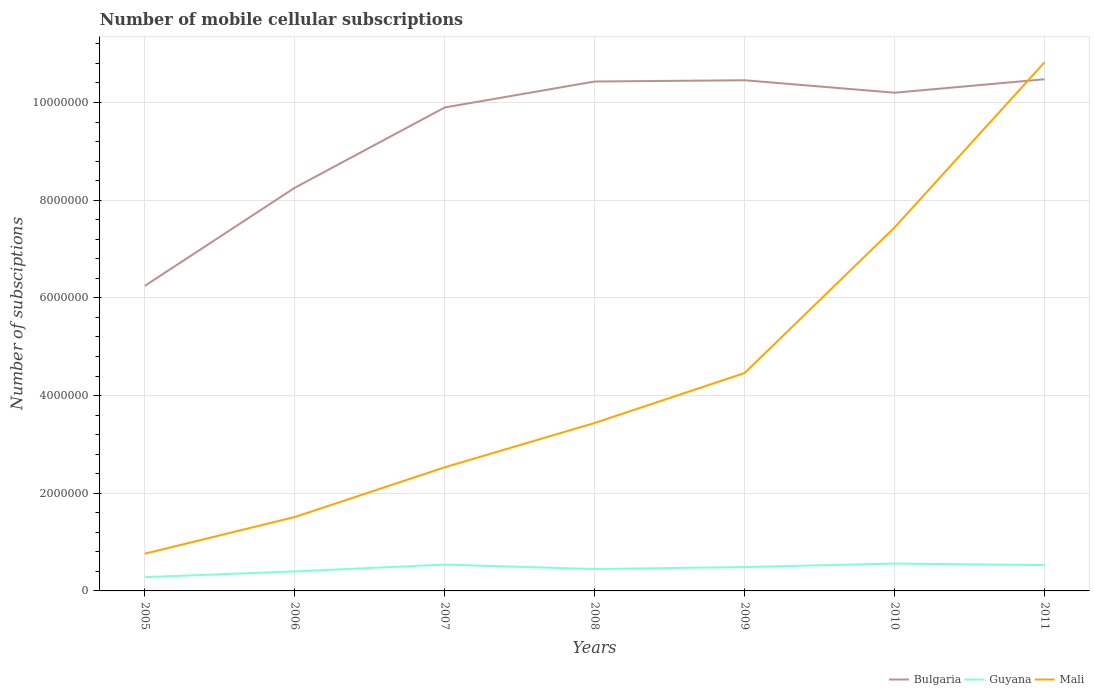How many different coloured lines are there?
Provide a short and direct response. 3. Is the number of lines equal to the number of legend labels?
Offer a terse response. Yes. Across all years, what is the maximum number of mobile cellular subscriptions in Bulgaria?
Keep it short and to the point. 6.24e+06. What is the total number of mobile cellular subscriptions in Bulgaria in the graph?
Provide a short and direct response. -2.18e+06. What is the difference between the highest and the second highest number of mobile cellular subscriptions in Guyana?
Your answer should be very brief. 2.79e+05. What is the difference between the highest and the lowest number of mobile cellular subscriptions in Bulgaria?
Offer a very short reply. 5. How many years are there in the graph?
Offer a terse response. 7. What is the difference between two consecutive major ticks on the Y-axis?
Offer a very short reply. 2.00e+06. Does the graph contain any zero values?
Provide a short and direct response. No. Does the graph contain grids?
Your answer should be very brief. Yes. How are the legend labels stacked?
Offer a very short reply. Horizontal. What is the title of the graph?
Keep it short and to the point. Number of mobile cellular subscriptions. What is the label or title of the X-axis?
Offer a terse response. Years. What is the label or title of the Y-axis?
Keep it short and to the point. Number of subsciptions. What is the Number of subsciptions in Bulgaria in 2005?
Provide a succinct answer. 6.24e+06. What is the Number of subsciptions in Guyana in 2005?
Offer a very short reply. 2.81e+05. What is the Number of subsciptions in Mali in 2005?
Offer a terse response. 7.62e+05. What is the Number of subsciptions of Bulgaria in 2006?
Provide a short and direct response. 8.25e+06. What is the Number of subsciptions in Mali in 2006?
Your answer should be very brief. 1.51e+06. What is the Number of subsciptions in Bulgaria in 2007?
Offer a terse response. 9.90e+06. What is the Number of subsciptions of Guyana in 2007?
Provide a short and direct response. 5.39e+05. What is the Number of subsciptions of Mali in 2007?
Your answer should be compact. 2.53e+06. What is the Number of subsciptions in Bulgaria in 2008?
Provide a short and direct response. 1.04e+07. What is the Number of subsciptions in Guyana in 2008?
Keep it short and to the point. 4.48e+05. What is the Number of subsciptions in Mali in 2008?
Offer a terse response. 3.44e+06. What is the Number of subsciptions of Bulgaria in 2009?
Offer a very short reply. 1.05e+07. What is the Number of subsciptions of Guyana in 2009?
Ensure brevity in your answer.  4.89e+05. What is the Number of subsciptions of Mali in 2009?
Offer a very short reply. 4.46e+06. What is the Number of subsciptions of Bulgaria in 2010?
Make the answer very short. 1.02e+07. What is the Number of subsciptions of Guyana in 2010?
Keep it short and to the point. 5.60e+05. What is the Number of subsciptions of Mali in 2010?
Your response must be concise. 7.44e+06. What is the Number of subsciptions in Bulgaria in 2011?
Make the answer very short. 1.05e+07. What is the Number of subsciptions of Guyana in 2011?
Make the answer very short. 5.29e+05. What is the Number of subsciptions in Mali in 2011?
Offer a very short reply. 1.08e+07. Across all years, what is the maximum Number of subsciptions of Bulgaria?
Provide a succinct answer. 1.05e+07. Across all years, what is the maximum Number of subsciptions of Guyana?
Your answer should be compact. 5.60e+05. Across all years, what is the maximum Number of subsciptions of Mali?
Offer a very short reply. 1.08e+07. Across all years, what is the minimum Number of subsciptions of Bulgaria?
Offer a very short reply. 6.24e+06. Across all years, what is the minimum Number of subsciptions in Guyana?
Give a very brief answer. 2.81e+05. Across all years, what is the minimum Number of subsciptions in Mali?
Your answer should be compact. 7.62e+05. What is the total Number of subsciptions in Bulgaria in the graph?
Your answer should be very brief. 6.60e+07. What is the total Number of subsciptions in Guyana in the graph?
Offer a very short reply. 3.25e+06. What is the total Number of subsciptions in Mali in the graph?
Your answer should be compact. 3.10e+07. What is the difference between the Number of subsciptions in Bulgaria in 2005 and that in 2006?
Keep it short and to the point. -2.01e+06. What is the difference between the Number of subsciptions of Guyana in 2005 and that in 2006?
Keep it short and to the point. -1.19e+05. What is the difference between the Number of subsciptions of Mali in 2005 and that in 2006?
Give a very brief answer. -7.51e+05. What is the difference between the Number of subsciptions of Bulgaria in 2005 and that in 2007?
Ensure brevity in your answer.  -3.65e+06. What is the difference between the Number of subsciptions of Guyana in 2005 and that in 2007?
Keep it short and to the point. -2.57e+05. What is the difference between the Number of subsciptions in Mali in 2005 and that in 2007?
Provide a short and direct response. -1.77e+06. What is the difference between the Number of subsciptions of Bulgaria in 2005 and that in 2008?
Your response must be concise. -4.18e+06. What is the difference between the Number of subsciptions of Guyana in 2005 and that in 2008?
Make the answer very short. -1.66e+05. What is the difference between the Number of subsciptions in Mali in 2005 and that in 2008?
Offer a very short reply. -2.68e+06. What is the difference between the Number of subsciptions of Bulgaria in 2005 and that in 2009?
Give a very brief answer. -4.21e+06. What is the difference between the Number of subsciptions of Guyana in 2005 and that in 2009?
Your answer should be very brief. -2.07e+05. What is the difference between the Number of subsciptions of Mali in 2005 and that in 2009?
Your response must be concise. -3.70e+06. What is the difference between the Number of subsciptions of Bulgaria in 2005 and that in 2010?
Offer a terse response. -3.96e+06. What is the difference between the Number of subsciptions of Guyana in 2005 and that in 2010?
Provide a short and direct response. -2.79e+05. What is the difference between the Number of subsciptions of Mali in 2005 and that in 2010?
Your answer should be very brief. -6.68e+06. What is the difference between the Number of subsciptions in Bulgaria in 2005 and that in 2011?
Make the answer very short. -4.23e+06. What is the difference between the Number of subsciptions of Guyana in 2005 and that in 2011?
Keep it short and to the point. -2.47e+05. What is the difference between the Number of subsciptions in Mali in 2005 and that in 2011?
Provide a succinct answer. -1.01e+07. What is the difference between the Number of subsciptions in Bulgaria in 2006 and that in 2007?
Your answer should be compact. -1.64e+06. What is the difference between the Number of subsciptions in Guyana in 2006 and that in 2007?
Ensure brevity in your answer.  -1.39e+05. What is the difference between the Number of subsciptions of Mali in 2006 and that in 2007?
Your answer should be very brief. -1.02e+06. What is the difference between the Number of subsciptions in Bulgaria in 2006 and that in 2008?
Ensure brevity in your answer.  -2.18e+06. What is the difference between the Number of subsciptions in Guyana in 2006 and that in 2008?
Keep it short and to the point. -4.78e+04. What is the difference between the Number of subsciptions in Mali in 2006 and that in 2008?
Your response must be concise. -1.93e+06. What is the difference between the Number of subsciptions of Bulgaria in 2006 and that in 2009?
Ensure brevity in your answer.  -2.20e+06. What is the difference between the Number of subsciptions of Guyana in 2006 and that in 2009?
Keep it short and to the point. -8.85e+04. What is the difference between the Number of subsciptions of Mali in 2006 and that in 2009?
Keep it short and to the point. -2.95e+06. What is the difference between the Number of subsciptions of Bulgaria in 2006 and that in 2010?
Ensure brevity in your answer.  -1.95e+06. What is the difference between the Number of subsciptions in Guyana in 2006 and that in 2010?
Provide a succinct answer. -1.60e+05. What is the difference between the Number of subsciptions in Mali in 2006 and that in 2010?
Your response must be concise. -5.93e+06. What is the difference between the Number of subsciptions of Bulgaria in 2006 and that in 2011?
Keep it short and to the point. -2.22e+06. What is the difference between the Number of subsciptions in Guyana in 2006 and that in 2011?
Make the answer very short. -1.29e+05. What is the difference between the Number of subsciptions of Mali in 2006 and that in 2011?
Your answer should be very brief. -9.31e+06. What is the difference between the Number of subsciptions in Bulgaria in 2007 and that in 2008?
Make the answer very short. -5.32e+05. What is the difference between the Number of subsciptions of Guyana in 2007 and that in 2008?
Your answer should be very brief. 9.10e+04. What is the difference between the Number of subsciptions of Mali in 2007 and that in 2008?
Your answer should be compact. -9.08e+05. What is the difference between the Number of subsciptions of Bulgaria in 2007 and that in 2009?
Keep it short and to the point. -5.57e+05. What is the difference between the Number of subsciptions of Guyana in 2007 and that in 2009?
Offer a terse response. 5.02e+04. What is the difference between the Number of subsciptions of Mali in 2007 and that in 2009?
Provide a short and direct response. -1.93e+06. What is the difference between the Number of subsciptions of Bulgaria in 2007 and that in 2010?
Your response must be concise. -3.02e+05. What is the difference between the Number of subsciptions of Guyana in 2007 and that in 2010?
Offer a terse response. -2.16e+04. What is the difference between the Number of subsciptions of Mali in 2007 and that in 2010?
Keep it short and to the point. -4.91e+06. What is the difference between the Number of subsciptions in Bulgaria in 2007 and that in 2011?
Offer a very short reply. -5.78e+05. What is the difference between the Number of subsciptions in Guyana in 2007 and that in 2011?
Offer a very short reply. 1.00e+04. What is the difference between the Number of subsciptions in Mali in 2007 and that in 2011?
Offer a very short reply. -8.29e+06. What is the difference between the Number of subsciptions in Bulgaria in 2008 and that in 2009?
Provide a succinct answer. -2.58e+04. What is the difference between the Number of subsciptions in Guyana in 2008 and that in 2009?
Your answer should be compact. -4.08e+04. What is the difference between the Number of subsciptions of Mali in 2008 and that in 2009?
Ensure brevity in your answer.  -1.02e+06. What is the difference between the Number of subsciptions of Bulgaria in 2008 and that in 2010?
Offer a terse response. 2.29e+05. What is the difference between the Number of subsciptions in Guyana in 2008 and that in 2010?
Offer a very short reply. -1.13e+05. What is the difference between the Number of subsciptions of Mali in 2008 and that in 2010?
Offer a very short reply. -4.00e+06. What is the difference between the Number of subsciptions in Bulgaria in 2008 and that in 2011?
Your answer should be very brief. -4.61e+04. What is the difference between the Number of subsciptions in Guyana in 2008 and that in 2011?
Offer a very short reply. -8.10e+04. What is the difference between the Number of subsciptions in Mali in 2008 and that in 2011?
Give a very brief answer. -7.38e+06. What is the difference between the Number of subsciptions of Bulgaria in 2009 and that in 2010?
Keep it short and to the point. 2.55e+05. What is the difference between the Number of subsciptions of Guyana in 2009 and that in 2010?
Your answer should be very brief. -7.19e+04. What is the difference between the Number of subsciptions of Mali in 2009 and that in 2010?
Keep it short and to the point. -2.98e+06. What is the difference between the Number of subsciptions of Bulgaria in 2009 and that in 2011?
Provide a short and direct response. -2.03e+04. What is the difference between the Number of subsciptions of Guyana in 2009 and that in 2011?
Give a very brief answer. -4.02e+04. What is the difference between the Number of subsciptions in Mali in 2009 and that in 2011?
Provide a succinct answer. -6.36e+06. What is the difference between the Number of subsciptions of Bulgaria in 2010 and that in 2011?
Make the answer very short. -2.75e+05. What is the difference between the Number of subsciptions in Guyana in 2010 and that in 2011?
Your answer should be very brief. 3.16e+04. What is the difference between the Number of subsciptions of Mali in 2010 and that in 2011?
Provide a succinct answer. -3.38e+06. What is the difference between the Number of subsciptions in Bulgaria in 2005 and the Number of subsciptions in Guyana in 2006?
Your response must be concise. 5.84e+06. What is the difference between the Number of subsciptions in Bulgaria in 2005 and the Number of subsciptions in Mali in 2006?
Your answer should be very brief. 4.73e+06. What is the difference between the Number of subsciptions in Guyana in 2005 and the Number of subsciptions in Mali in 2006?
Your answer should be compact. -1.23e+06. What is the difference between the Number of subsciptions in Bulgaria in 2005 and the Number of subsciptions in Guyana in 2007?
Make the answer very short. 5.71e+06. What is the difference between the Number of subsciptions of Bulgaria in 2005 and the Number of subsciptions of Mali in 2007?
Provide a short and direct response. 3.71e+06. What is the difference between the Number of subsciptions of Guyana in 2005 and the Number of subsciptions of Mali in 2007?
Offer a very short reply. -2.25e+06. What is the difference between the Number of subsciptions of Bulgaria in 2005 and the Number of subsciptions of Guyana in 2008?
Your response must be concise. 5.80e+06. What is the difference between the Number of subsciptions in Bulgaria in 2005 and the Number of subsciptions in Mali in 2008?
Provide a short and direct response. 2.81e+06. What is the difference between the Number of subsciptions in Guyana in 2005 and the Number of subsciptions in Mali in 2008?
Provide a short and direct response. -3.16e+06. What is the difference between the Number of subsciptions in Bulgaria in 2005 and the Number of subsciptions in Guyana in 2009?
Offer a terse response. 5.76e+06. What is the difference between the Number of subsciptions of Bulgaria in 2005 and the Number of subsciptions of Mali in 2009?
Keep it short and to the point. 1.78e+06. What is the difference between the Number of subsciptions in Guyana in 2005 and the Number of subsciptions in Mali in 2009?
Provide a succinct answer. -4.18e+06. What is the difference between the Number of subsciptions of Bulgaria in 2005 and the Number of subsciptions of Guyana in 2010?
Your response must be concise. 5.68e+06. What is the difference between the Number of subsciptions of Bulgaria in 2005 and the Number of subsciptions of Mali in 2010?
Ensure brevity in your answer.  -1.20e+06. What is the difference between the Number of subsciptions in Guyana in 2005 and the Number of subsciptions in Mali in 2010?
Provide a short and direct response. -7.16e+06. What is the difference between the Number of subsciptions in Bulgaria in 2005 and the Number of subsciptions in Guyana in 2011?
Your answer should be compact. 5.72e+06. What is the difference between the Number of subsciptions of Bulgaria in 2005 and the Number of subsciptions of Mali in 2011?
Your answer should be compact. -4.58e+06. What is the difference between the Number of subsciptions of Guyana in 2005 and the Number of subsciptions of Mali in 2011?
Provide a short and direct response. -1.05e+07. What is the difference between the Number of subsciptions of Bulgaria in 2006 and the Number of subsciptions of Guyana in 2007?
Your response must be concise. 7.71e+06. What is the difference between the Number of subsciptions in Bulgaria in 2006 and the Number of subsciptions in Mali in 2007?
Provide a short and direct response. 5.72e+06. What is the difference between the Number of subsciptions of Guyana in 2006 and the Number of subsciptions of Mali in 2007?
Your answer should be compact. -2.13e+06. What is the difference between the Number of subsciptions in Bulgaria in 2006 and the Number of subsciptions in Guyana in 2008?
Make the answer very short. 7.81e+06. What is the difference between the Number of subsciptions in Bulgaria in 2006 and the Number of subsciptions in Mali in 2008?
Offer a very short reply. 4.81e+06. What is the difference between the Number of subsciptions in Guyana in 2006 and the Number of subsciptions in Mali in 2008?
Give a very brief answer. -3.04e+06. What is the difference between the Number of subsciptions of Bulgaria in 2006 and the Number of subsciptions of Guyana in 2009?
Provide a succinct answer. 7.76e+06. What is the difference between the Number of subsciptions of Bulgaria in 2006 and the Number of subsciptions of Mali in 2009?
Ensure brevity in your answer.  3.79e+06. What is the difference between the Number of subsciptions of Guyana in 2006 and the Number of subsciptions of Mali in 2009?
Make the answer very short. -4.06e+06. What is the difference between the Number of subsciptions of Bulgaria in 2006 and the Number of subsciptions of Guyana in 2010?
Provide a succinct answer. 7.69e+06. What is the difference between the Number of subsciptions in Bulgaria in 2006 and the Number of subsciptions in Mali in 2010?
Give a very brief answer. 8.13e+05. What is the difference between the Number of subsciptions in Guyana in 2006 and the Number of subsciptions in Mali in 2010?
Your response must be concise. -7.04e+06. What is the difference between the Number of subsciptions in Bulgaria in 2006 and the Number of subsciptions in Guyana in 2011?
Keep it short and to the point. 7.72e+06. What is the difference between the Number of subsciptions in Bulgaria in 2006 and the Number of subsciptions in Mali in 2011?
Ensure brevity in your answer.  -2.57e+06. What is the difference between the Number of subsciptions of Guyana in 2006 and the Number of subsciptions of Mali in 2011?
Your answer should be compact. -1.04e+07. What is the difference between the Number of subsciptions of Bulgaria in 2007 and the Number of subsciptions of Guyana in 2008?
Give a very brief answer. 9.45e+06. What is the difference between the Number of subsciptions in Bulgaria in 2007 and the Number of subsciptions in Mali in 2008?
Your response must be concise. 6.46e+06. What is the difference between the Number of subsciptions in Guyana in 2007 and the Number of subsciptions in Mali in 2008?
Give a very brief answer. -2.90e+06. What is the difference between the Number of subsciptions of Bulgaria in 2007 and the Number of subsciptions of Guyana in 2009?
Keep it short and to the point. 9.41e+06. What is the difference between the Number of subsciptions in Bulgaria in 2007 and the Number of subsciptions in Mali in 2009?
Ensure brevity in your answer.  5.44e+06. What is the difference between the Number of subsciptions in Guyana in 2007 and the Number of subsciptions in Mali in 2009?
Ensure brevity in your answer.  -3.92e+06. What is the difference between the Number of subsciptions of Bulgaria in 2007 and the Number of subsciptions of Guyana in 2010?
Your response must be concise. 9.34e+06. What is the difference between the Number of subsciptions in Bulgaria in 2007 and the Number of subsciptions in Mali in 2010?
Your answer should be compact. 2.46e+06. What is the difference between the Number of subsciptions of Guyana in 2007 and the Number of subsciptions of Mali in 2010?
Provide a succinct answer. -6.90e+06. What is the difference between the Number of subsciptions of Bulgaria in 2007 and the Number of subsciptions of Guyana in 2011?
Your response must be concise. 9.37e+06. What is the difference between the Number of subsciptions of Bulgaria in 2007 and the Number of subsciptions of Mali in 2011?
Provide a short and direct response. -9.24e+05. What is the difference between the Number of subsciptions of Guyana in 2007 and the Number of subsciptions of Mali in 2011?
Offer a terse response. -1.03e+07. What is the difference between the Number of subsciptions of Bulgaria in 2008 and the Number of subsciptions of Guyana in 2009?
Provide a succinct answer. 9.94e+06. What is the difference between the Number of subsciptions in Bulgaria in 2008 and the Number of subsciptions in Mali in 2009?
Keep it short and to the point. 5.97e+06. What is the difference between the Number of subsciptions in Guyana in 2008 and the Number of subsciptions in Mali in 2009?
Your answer should be very brief. -4.01e+06. What is the difference between the Number of subsciptions of Bulgaria in 2008 and the Number of subsciptions of Guyana in 2010?
Offer a very short reply. 9.87e+06. What is the difference between the Number of subsciptions of Bulgaria in 2008 and the Number of subsciptions of Mali in 2010?
Provide a short and direct response. 2.99e+06. What is the difference between the Number of subsciptions in Guyana in 2008 and the Number of subsciptions in Mali in 2010?
Your answer should be very brief. -6.99e+06. What is the difference between the Number of subsciptions of Bulgaria in 2008 and the Number of subsciptions of Guyana in 2011?
Offer a very short reply. 9.90e+06. What is the difference between the Number of subsciptions of Bulgaria in 2008 and the Number of subsciptions of Mali in 2011?
Offer a terse response. -3.93e+05. What is the difference between the Number of subsciptions in Guyana in 2008 and the Number of subsciptions in Mali in 2011?
Ensure brevity in your answer.  -1.04e+07. What is the difference between the Number of subsciptions in Bulgaria in 2009 and the Number of subsciptions in Guyana in 2010?
Your answer should be very brief. 9.89e+06. What is the difference between the Number of subsciptions of Bulgaria in 2009 and the Number of subsciptions of Mali in 2010?
Give a very brief answer. 3.01e+06. What is the difference between the Number of subsciptions of Guyana in 2009 and the Number of subsciptions of Mali in 2010?
Keep it short and to the point. -6.95e+06. What is the difference between the Number of subsciptions in Bulgaria in 2009 and the Number of subsciptions in Guyana in 2011?
Your answer should be very brief. 9.93e+06. What is the difference between the Number of subsciptions of Bulgaria in 2009 and the Number of subsciptions of Mali in 2011?
Ensure brevity in your answer.  -3.67e+05. What is the difference between the Number of subsciptions of Guyana in 2009 and the Number of subsciptions of Mali in 2011?
Ensure brevity in your answer.  -1.03e+07. What is the difference between the Number of subsciptions in Bulgaria in 2010 and the Number of subsciptions in Guyana in 2011?
Make the answer very short. 9.67e+06. What is the difference between the Number of subsciptions in Bulgaria in 2010 and the Number of subsciptions in Mali in 2011?
Make the answer very short. -6.22e+05. What is the difference between the Number of subsciptions in Guyana in 2010 and the Number of subsciptions in Mali in 2011?
Ensure brevity in your answer.  -1.03e+07. What is the average Number of subsciptions in Bulgaria per year?
Provide a short and direct response. 9.42e+06. What is the average Number of subsciptions of Guyana per year?
Offer a very short reply. 4.64e+05. What is the average Number of subsciptions of Mali per year?
Provide a succinct answer. 4.42e+06. In the year 2005, what is the difference between the Number of subsciptions in Bulgaria and Number of subsciptions in Guyana?
Give a very brief answer. 5.96e+06. In the year 2005, what is the difference between the Number of subsciptions of Bulgaria and Number of subsciptions of Mali?
Offer a very short reply. 5.48e+06. In the year 2005, what is the difference between the Number of subsciptions of Guyana and Number of subsciptions of Mali?
Ensure brevity in your answer.  -4.81e+05. In the year 2006, what is the difference between the Number of subsciptions of Bulgaria and Number of subsciptions of Guyana?
Your answer should be compact. 7.85e+06. In the year 2006, what is the difference between the Number of subsciptions in Bulgaria and Number of subsciptions in Mali?
Make the answer very short. 6.74e+06. In the year 2006, what is the difference between the Number of subsciptions in Guyana and Number of subsciptions in Mali?
Offer a terse response. -1.11e+06. In the year 2007, what is the difference between the Number of subsciptions in Bulgaria and Number of subsciptions in Guyana?
Your response must be concise. 9.36e+06. In the year 2007, what is the difference between the Number of subsciptions in Bulgaria and Number of subsciptions in Mali?
Make the answer very short. 7.37e+06. In the year 2007, what is the difference between the Number of subsciptions of Guyana and Number of subsciptions of Mali?
Your answer should be very brief. -1.99e+06. In the year 2008, what is the difference between the Number of subsciptions of Bulgaria and Number of subsciptions of Guyana?
Give a very brief answer. 9.98e+06. In the year 2008, what is the difference between the Number of subsciptions of Bulgaria and Number of subsciptions of Mali?
Your response must be concise. 6.99e+06. In the year 2008, what is the difference between the Number of subsciptions of Guyana and Number of subsciptions of Mali?
Your response must be concise. -2.99e+06. In the year 2009, what is the difference between the Number of subsciptions in Bulgaria and Number of subsciptions in Guyana?
Your response must be concise. 9.97e+06. In the year 2009, what is the difference between the Number of subsciptions of Bulgaria and Number of subsciptions of Mali?
Provide a succinct answer. 5.99e+06. In the year 2009, what is the difference between the Number of subsciptions in Guyana and Number of subsciptions in Mali?
Your answer should be very brief. -3.97e+06. In the year 2010, what is the difference between the Number of subsciptions of Bulgaria and Number of subsciptions of Guyana?
Provide a short and direct response. 9.64e+06. In the year 2010, what is the difference between the Number of subsciptions in Bulgaria and Number of subsciptions in Mali?
Offer a terse response. 2.76e+06. In the year 2010, what is the difference between the Number of subsciptions in Guyana and Number of subsciptions in Mali?
Provide a succinct answer. -6.88e+06. In the year 2011, what is the difference between the Number of subsciptions of Bulgaria and Number of subsciptions of Guyana?
Make the answer very short. 9.95e+06. In the year 2011, what is the difference between the Number of subsciptions in Bulgaria and Number of subsciptions in Mali?
Keep it short and to the point. -3.47e+05. In the year 2011, what is the difference between the Number of subsciptions of Guyana and Number of subsciptions of Mali?
Your response must be concise. -1.03e+07. What is the ratio of the Number of subsciptions of Bulgaria in 2005 to that in 2006?
Provide a succinct answer. 0.76. What is the ratio of the Number of subsciptions of Guyana in 2005 to that in 2006?
Offer a very short reply. 0.7. What is the ratio of the Number of subsciptions of Mali in 2005 to that in 2006?
Your answer should be compact. 0.5. What is the ratio of the Number of subsciptions in Bulgaria in 2005 to that in 2007?
Offer a very short reply. 0.63. What is the ratio of the Number of subsciptions of Guyana in 2005 to that in 2007?
Provide a short and direct response. 0.52. What is the ratio of the Number of subsciptions of Mali in 2005 to that in 2007?
Your response must be concise. 0.3. What is the ratio of the Number of subsciptions of Bulgaria in 2005 to that in 2008?
Give a very brief answer. 0.6. What is the ratio of the Number of subsciptions in Guyana in 2005 to that in 2008?
Provide a succinct answer. 0.63. What is the ratio of the Number of subsciptions in Mali in 2005 to that in 2008?
Make the answer very short. 0.22. What is the ratio of the Number of subsciptions of Bulgaria in 2005 to that in 2009?
Provide a short and direct response. 0.6. What is the ratio of the Number of subsciptions of Guyana in 2005 to that in 2009?
Give a very brief answer. 0.58. What is the ratio of the Number of subsciptions of Mali in 2005 to that in 2009?
Keep it short and to the point. 0.17. What is the ratio of the Number of subsciptions of Bulgaria in 2005 to that in 2010?
Make the answer very short. 0.61. What is the ratio of the Number of subsciptions of Guyana in 2005 to that in 2010?
Provide a short and direct response. 0.5. What is the ratio of the Number of subsciptions of Mali in 2005 to that in 2010?
Offer a very short reply. 0.1. What is the ratio of the Number of subsciptions in Bulgaria in 2005 to that in 2011?
Ensure brevity in your answer.  0.6. What is the ratio of the Number of subsciptions in Guyana in 2005 to that in 2011?
Offer a terse response. 0.53. What is the ratio of the Number of subsciptions in Mali in 2005 to that in 2011?
Offer a terse response. 0.07. What is the ratio of the Number of subsciptions of Bulgaria in 2006 to that in 2007?
Provide a succinct answer. 0.83. What is the ratio of the Number of subsciptions in Guyana in 2006 to that in 2007?
Your answer should be very brief. 0.74. What is the ratio of the Number of subsciptions in Mali in 2006 to that in 2007?
Provide a short and direct response. 0.6. What is the ratio of the Number of subsciptions of Bulgaria in 2006 to that in 2008?
Keep it short and to the point. 0.79. What is the ratio of the Number of subsciptions of Guyana in 2006 to that in 2008?
Give a very brief answer. 0.89. What is the ratio of the Number of subsciptions of Mali in 2006 to that in 2008?
Ensure brevity in your answer.  0.44. What is the ratio of the Number of subsciptions in Bulgaria in 2006 to that in 2009?
Provide a succinct answer. 0.79. What is the ratio of the Number of subsciptions in Guyana in 2006 to that in 2009?
Give a very brief answer. 0.82. What is the ratio of the Number of subsciptions in Mali in 2006 to that in 2009?
Provide a short and direct response. 0.34. What is the ratio of the Number of subsciptions of Bulgaria in 2006 to that in 2010?
Make the answer very short. 0.81. What is the ratio of the Number of subsciptions in Guyana in 2006 to that in 2010?
Make the answer very short. 0.71. What is the ratio of the Number of subsciptions in Mali in 2006 to that in 2010?
Offer a terse response. 0.2. What is the ratio of the Number of subsciptions of Bulgaria in 2006 to that in 2011?
Offer a very short reply. 0.79. What is the ratio of the Number of subsciptions of Guyana in 2006 to that in 2011?
Provide a short and direct response. 0.76. What is the ratio of the Number of subsciptions of Mali in 2006 to that in 2011?
Offer a very short reply. 0.14. What is the ratio of the Number of subsciptions in Bulgaria in 2007 to that in 2008?
Provide a short and direct response. 0.95. What is the ratio of the Number of subsciptions in Guyana in 2007 to that in 2008?
Keep it short and to the point. 1.2. What is the ratio of the Number of subsciptions in Mali in 2007 to that in 2008?
Offer a terse response. 0.74. What is the ratio of the Number of subsciptions in Bulgaria in 2007 to that in 2009?
Provide a succinct answer. 0.95. What is the ratio of the Number of subsciptions of Guyana in 2007 to that in 2009?
Provide a succinct answer. 1.1. What is the ratio of the Number of subsciptions in Mali in 2007 to that in 2009?
Offer a very short reply. 0.57. What is the ratio of the Number of subsciptions in Bulgaria in 2007 to that in 2010?
Make the answer very short. 0.97. What is the ratio of the Number of subsciptions of Guyana in 2007 to that in 2010?
Give a very brief answer. 0.96. What is the ratio of the Number of subsciptions of Mali in 2007 to that in 2010?
Give a very brief answer. 0.34. What is the ratio of the Number of subsciptions in Bulgaria in 2007 to that in 2011?
Offer a very short reply. 0.94. What is the ratio of the Number of subsciptions in Guyana in 2007 to that in 2011?
Your response must be concise. 1.02. What is the ratio of the Number of subsciptions in Mali in 2007 to that in 2011?
Your answer should be compact. 0.23. What is the ratio of the Number of subsciptions of Bulgaria in 2008 to that in 2009?
Keep it short and to the point. 1. What is the ratio of the Number of subsciptions in Guyana in 2008 to that in 2009?
Ensure brevity in your answer.  0.92. What is the ratio of the Number of subsciptions of Mali in 2008 to that in 2009?
Give a very brief answer. 0.77. What is the ratio of the Number of subsciptions of Bulgaria in 2008 to that in 2010?
Give a very brief answer. 1.02. What is the ratio of the Number of subsciptions in Guyana in 2008 to that in 2010?
Keep it short and to the point. 0.8. What is the ratio of the Number of subsciptions in Mali in 2008 to that in 2010?
Your answer should be compact. 0.46. What is the ratio of the Number of subsciptions in Guyana in 2008 to that in 2011?
Make the answer very short. 0.85. What is the ratio of the Number of subsciptions in Mali in 2008 to that in 2011?
Your response must be concise. 0.32. What is the ratio of the Number of subsciptions in Bulgaria in 2009 to that in 2010?
Give a very brief answer. 1.02. What is the ratio of the Number of subsciptions of Guyana in 2009 to that in 2010?
Keep it short and to the point. 0.87. What is the ratio of the Number of subsciptions in Mali in 2009 to that in 2010?
Offer a very short reply. 0.6. What is the ratio of the Number of subsciptions in Guyana in 2009 to that in 2011?
Give a very brief answer. 0.92. What is the ratio of the Number of subsciptions of Mali in 2009 to that in 2011?
Ensure brevity in your answer.  0.41. What is the ratio of the Number of subsciptions in Bulgaria in 2010 to that in 2011?
Give a very brief answer. 0.97. What is the ratio of the Number of subsciptions in Guyana in 2010 to that in 2011?
Offer a terse response. 1.06. What is the ratio of the Number of subsciptions of Mali in 2010 to that in 2011?
Make the answer very short. 0.69. What is the difference between the highest and the second highest Number of subsciptions in Bulgaria?
Keep it short and to the point. 2.03e+04. What is the difference between the highest and the second highest Number of subsciptions of Guyana?
Provide a short and direct response. 2.16e+04. What is the difference between the highest and the second highest Number of subsciptions in Mali?
Offer a terse response. 3.38e+06. What is the difference between the highest and the lowest Number of subsciptions in Bulgaria?
Offer a terse response. 4.23e+06. What is the difference between the highest and the lowest Number of subsciptions of Guyana?
Give a very brief answer. 2.79e+05. What is the difference between the highest and the lowest Number of subsciptions in Mali?
Offer a terse response. 1.01e+07. 